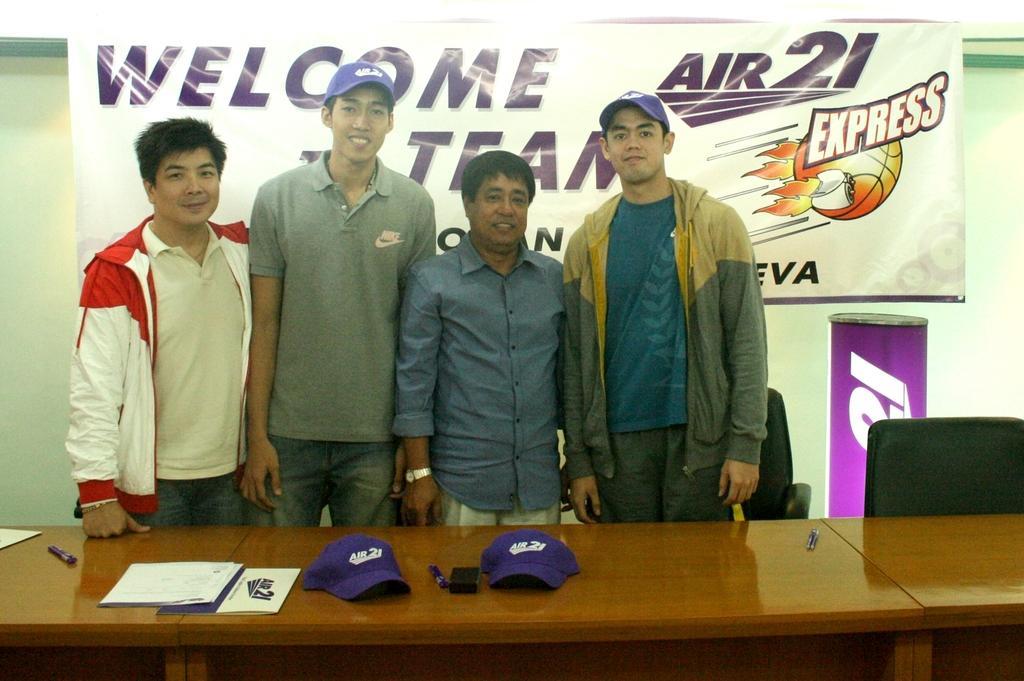In one or two sentences, can you explain what this image depicts? In this picture there are four people those who are standing in front of the wooden desk, and there are some papers and caps on the table, there is a banner behind the people, its written on it like welcome team express. 